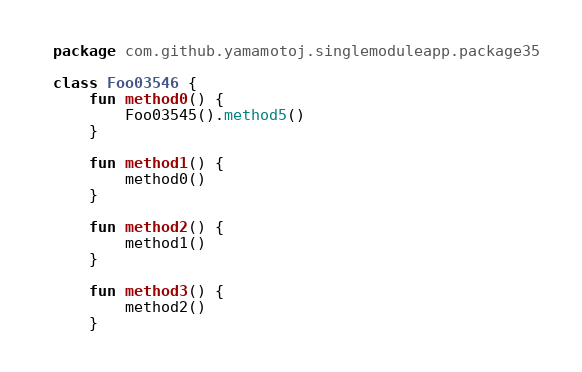<code> <loc_0><loc_0><loc_500><loc_500><_Kotlin_>package com.github.yamamotoj.singlemoduleapp.package35

class Foo03546 {
    fun method0() {
        Foo03545().method5()
    }

    fun method1() {
        method0()
    }

    fun method2() {
        method1()
    }

    fun method3() {
        method2()
    }
</code> 